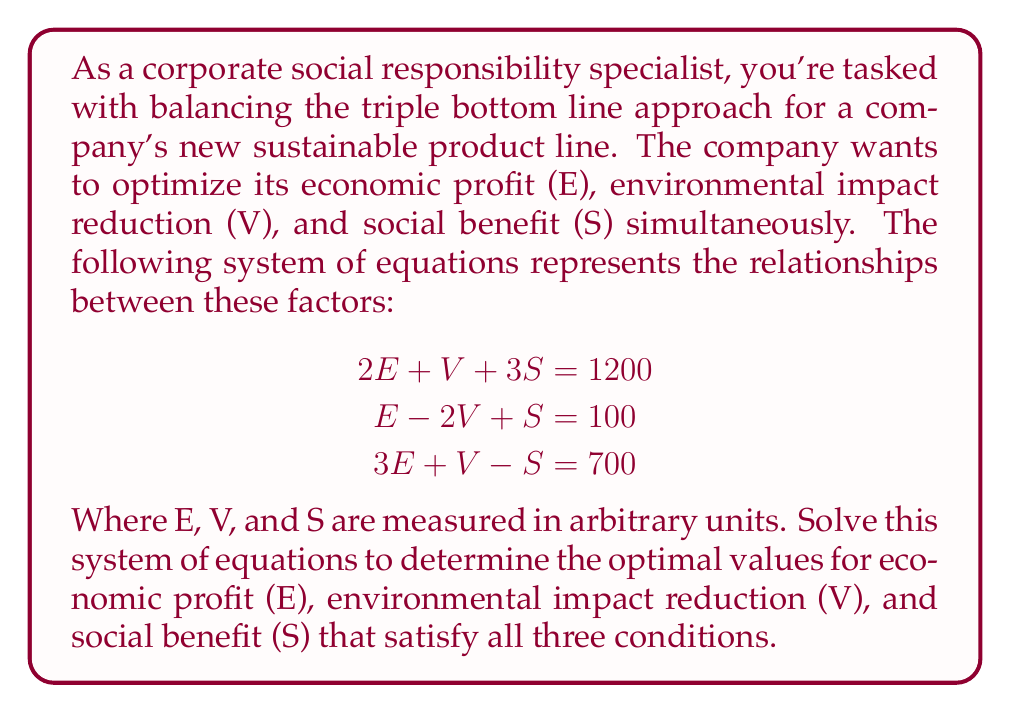What is the answer to this math problem? To solve this system of linear equations, we'll use the Gaussian elimination method.

Step 1: Write the augmented matrix for the system of equations.
$$\begin{bmatrix}
2 & 1 & 3 & 1200 \\
1 & -2 & 1 & 100 \\
3 & 1 & -1 & 700
\end{bmatrix}$$

Step 2: Use row operations to transform the matrix into row echelon form.

First, multiply the first row by -1/2 and add it to the second row:
$$\begin{bmatrix}
2 & 1 & 3 & 1200 \\
0 & -2.5 & -0.5 & -500 \\
3 & 1 & -1 & 700
\end{bmatrix}$$

Now, multiply the first row by -3/2 and add it to the third row:
$$\begin{bmatrix}
2 & 1 & 3 & 1200 \\
0 & -2.5 & -0.5 & -500 \\
0 & -0.5 & -5.5 & -1100
\end{bmatrix}$$

Step 3: Continue transforming the matrix into reduced row echelon form.

Multiply the second row by -1/2.5 to make the leading coefficient 1:
$$\begin{bmatrix}
2 & 1 & 3 & 1200 \\
0 & 1 & 0.2 & 200 \\
0 & -0.5 & -5.5 & -1100
\end{bmatrix}$$

Add 0.5 times the second row to the third row:
$$\begin{bmatrix}
2 & 1 & 3 & 1200 \\
0 & 1 & 0.2 & 200 \\
0 & 0 & -5.4 & -1000
\end{bmatrix}$$

Multiply the third row by -1/5.4 to make the leading coefficient 1:
$$\begin{bmatrix}
2 & 1 & 3 & 1200 \\
0 & 1 & 0.2 & 200 \\
0 & 0 & 1 & 185.19
\end{bmatrix}$$

Step 4: Use back-substitution to find the values of E, V, and S.

From the third row: $S = 185.19$

Substitute this into the second row:
$V + 0.2(185.19) = 200$
$V = 200 - 37.04 = 162.96$

Finally, substitute S and V into the first row:
$2E + 162.96 + 3(185.19) = 1200$
$2E = 1200 - 162.96 - 555.57 = 481.47$
$E = 240.74$

Step 5: Round the results to two decimal places for practicality.

E = 240.74
V = 162.96
S = 185.19
Answer: The optimal values that balance the triple bottom line approach are:
Economic profit (E) = 240.74 units
Environmental impact reduction (V) = 162.96 units
Social benefit (S) = 185.19 units 